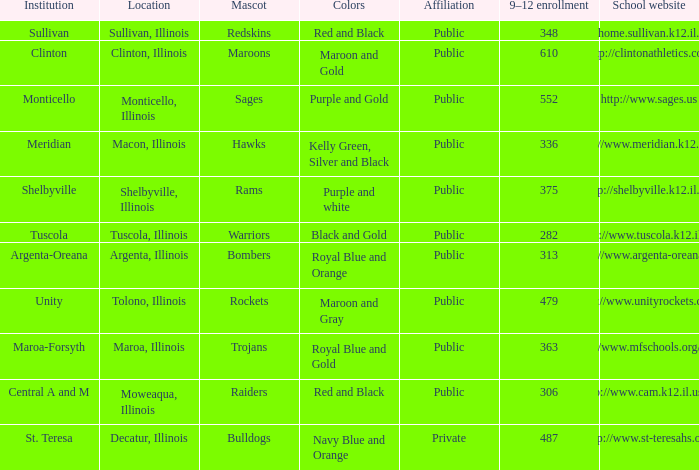What location has 363 students enrolled in the 9th to 12th grades? Maroa, Illinois. 